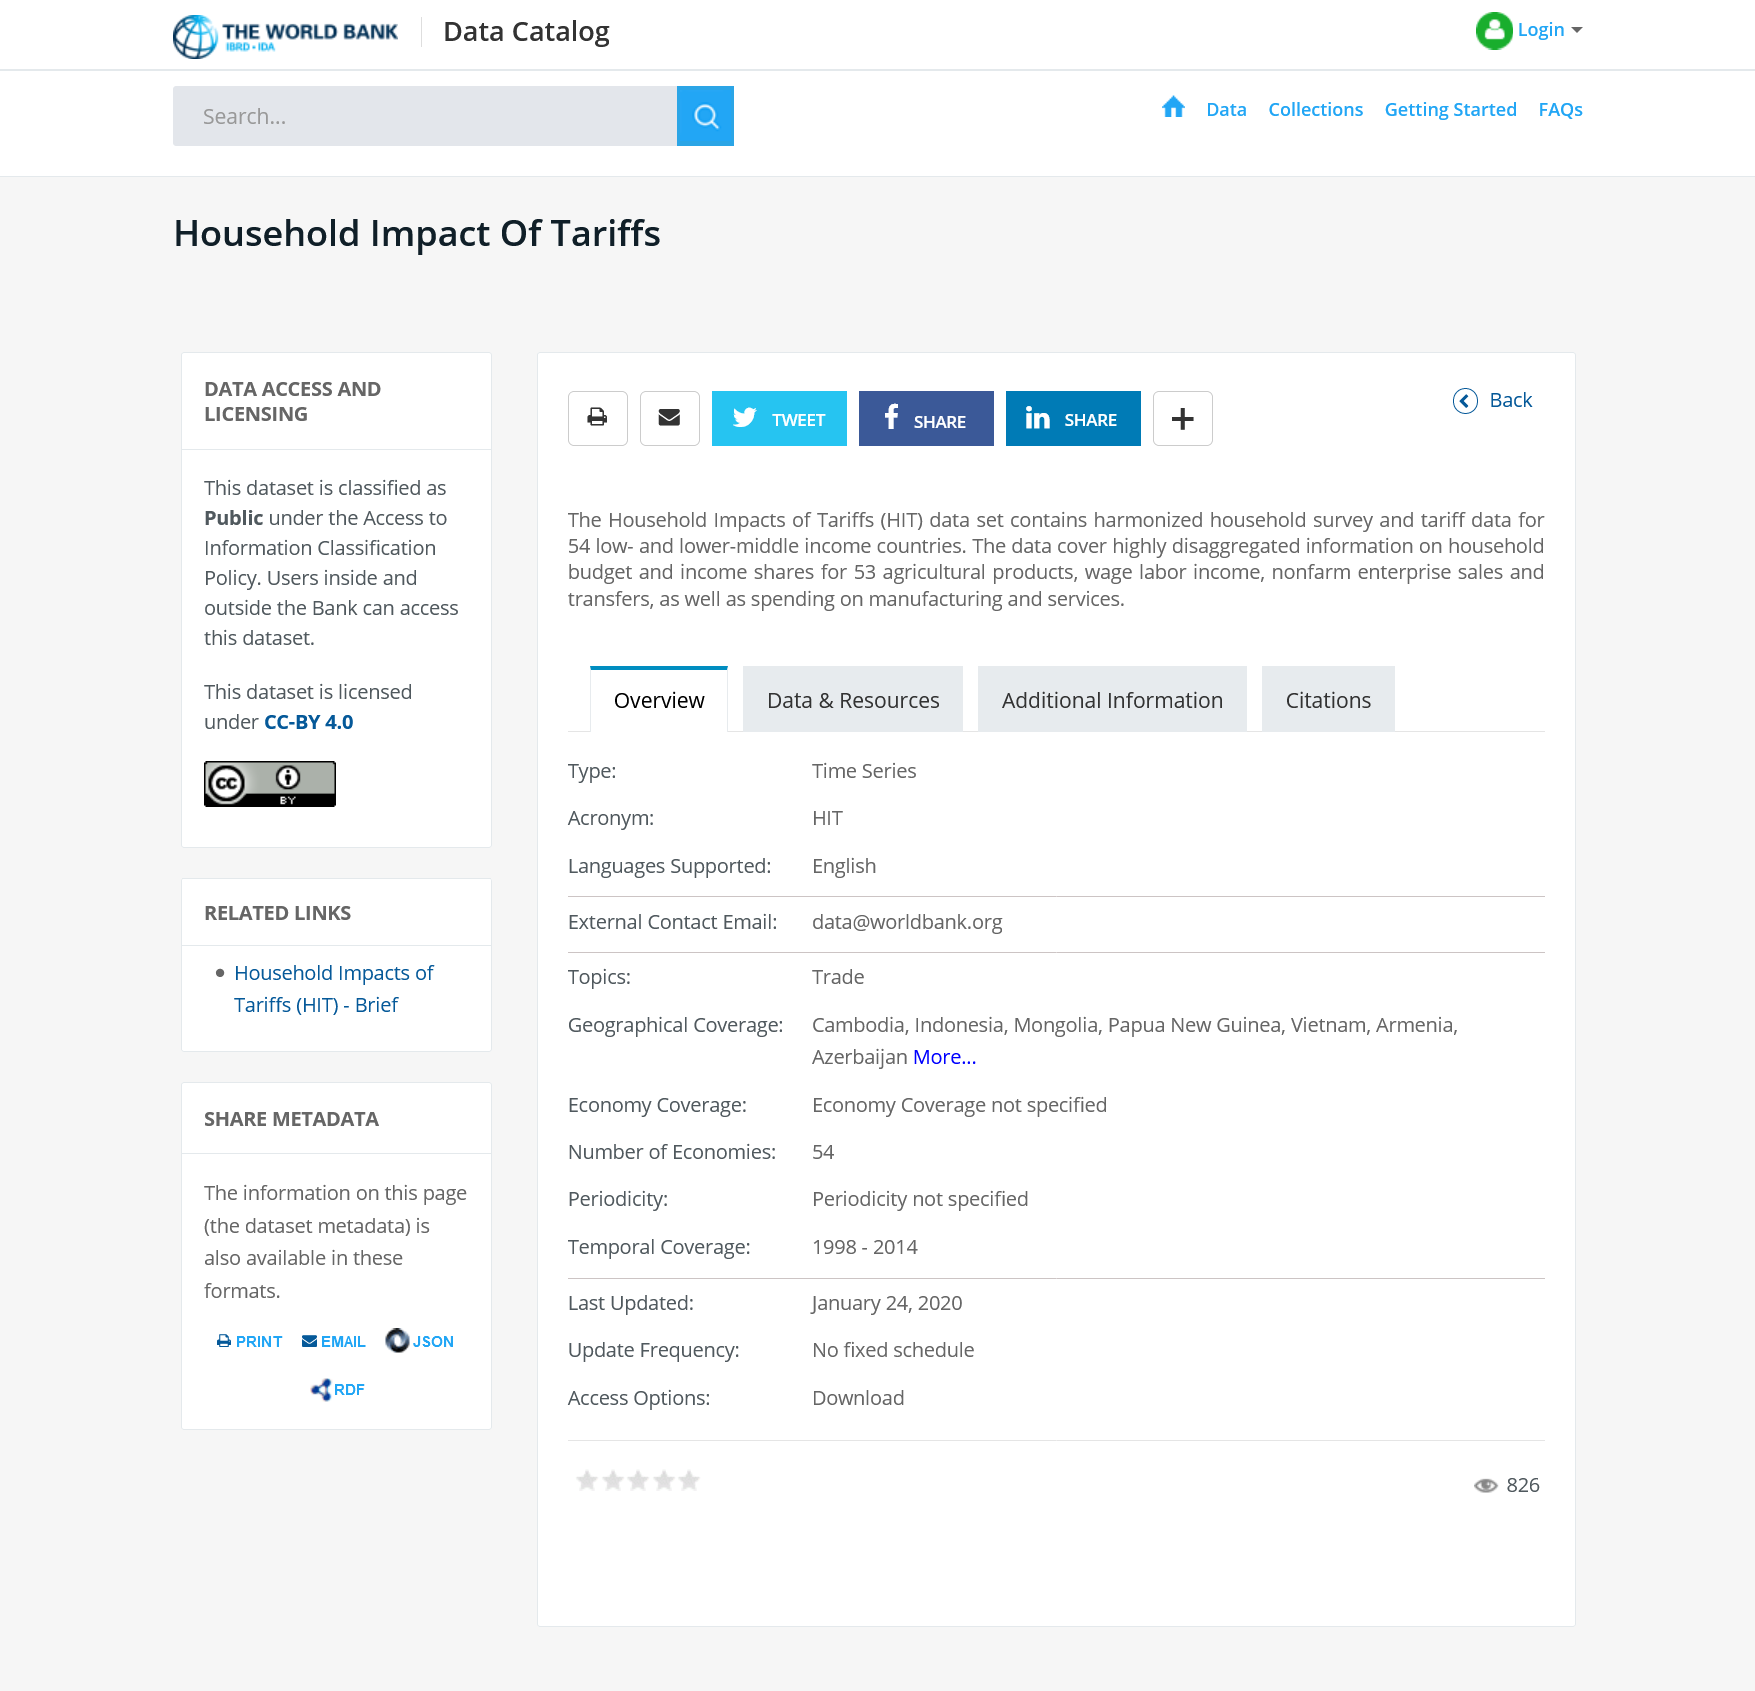Identify some key points in this picture. This dataset has been classified as public. The dataset contains data from 54 countries. This dataset is called the Household Impact of Tariffs and it is accessible to both Bank users within and outside the organization. 